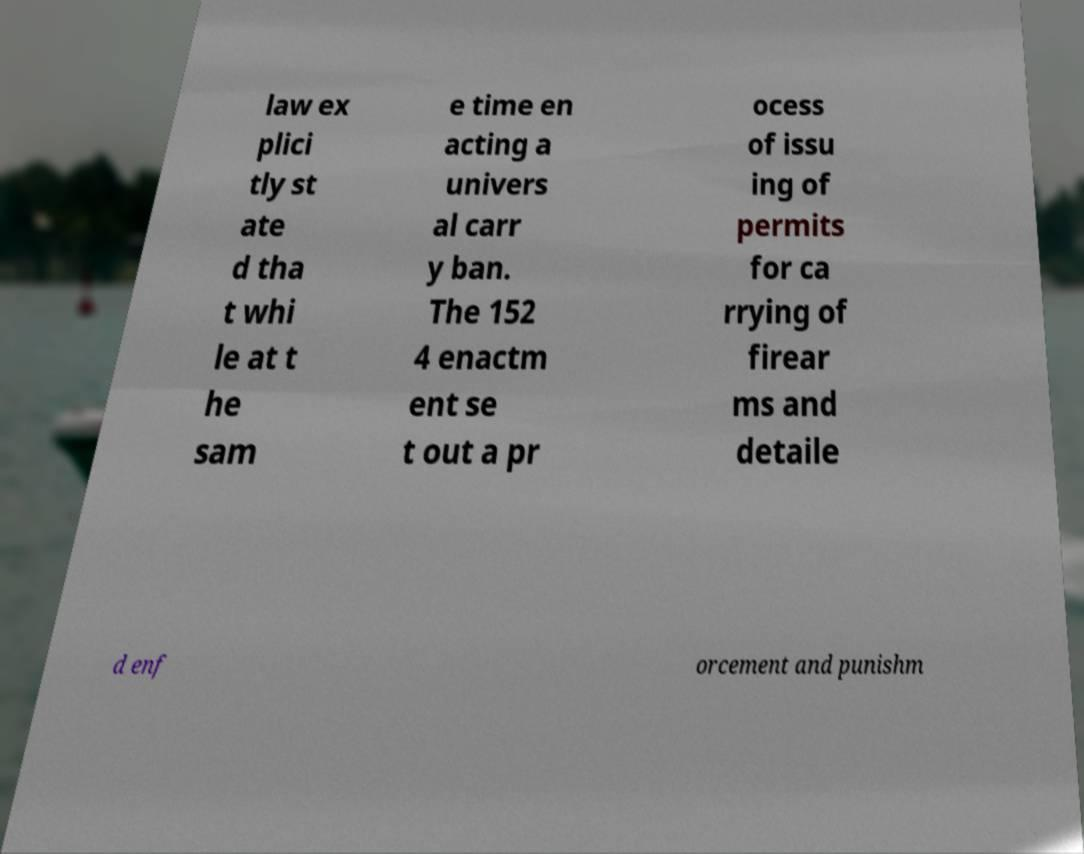There's text embedded in this image that I need extracted. Can you transcribe it verbatim? law ex plici tly st ate d tha t whi le at t he sam e time en acting a univers al carr y ban. The 152 4 enactm ent se t out a pr ocess of issu ing of permits for ca rrying of firear ms and detaile d enf orcement and punishm 